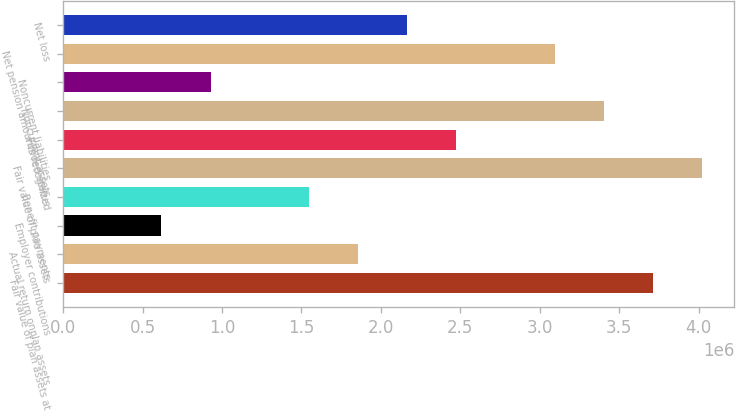Convert chart to OTSL. <chart><loc_0><loc_0><loc_500><loc_500><bar_chart><fcel>Fair value of plan assets at<fcel>Actual return onplan assets<fcel>Employer contributions<fcel>Benefit payments<fcel>Fair value of plan assets<fcel>Funded status<fcel>Noncurrent assets<fcel>Noncurrent liabilities<fcel>Net pension amounts recognized<fcel>Net loss<nl><fcel>3.71224e+06<fcel>1.85612e+06<fcel>618710<fcel>1.54677e+06<fcel>4.0216e+06<fcel>2.47483e+06<fcel>3.40289e+06<fcel>928063<fcel>3.09354e+06<fcel>2.16548e+06<nl></chart> 